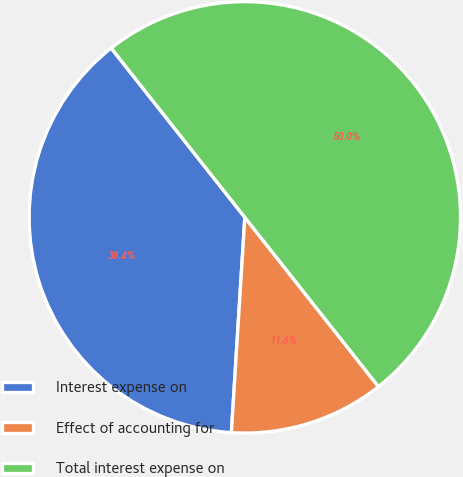Convert chart. <chart><loc_0><loc_0><loc_500><loc_500><pie_chart><fcel>Interest expense on<fcel>Effect of accounting for<fcel>Total interest expense on<nl><fcel>38.37%<fcel>11.63%<fcel>50.0%<nl></chart> 